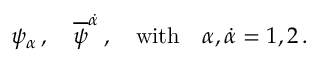Convert formula to latex. <formula><loc_0><loc_0><loc_500><loc_500>\psi _ { \alpha } \, , \quad \overline { \psi } ^ { \dot { \alpha } } \, , \quad w i t h \quad \alpha , { \dot { \alpha } } = 1 , 2 \, .</formula> 